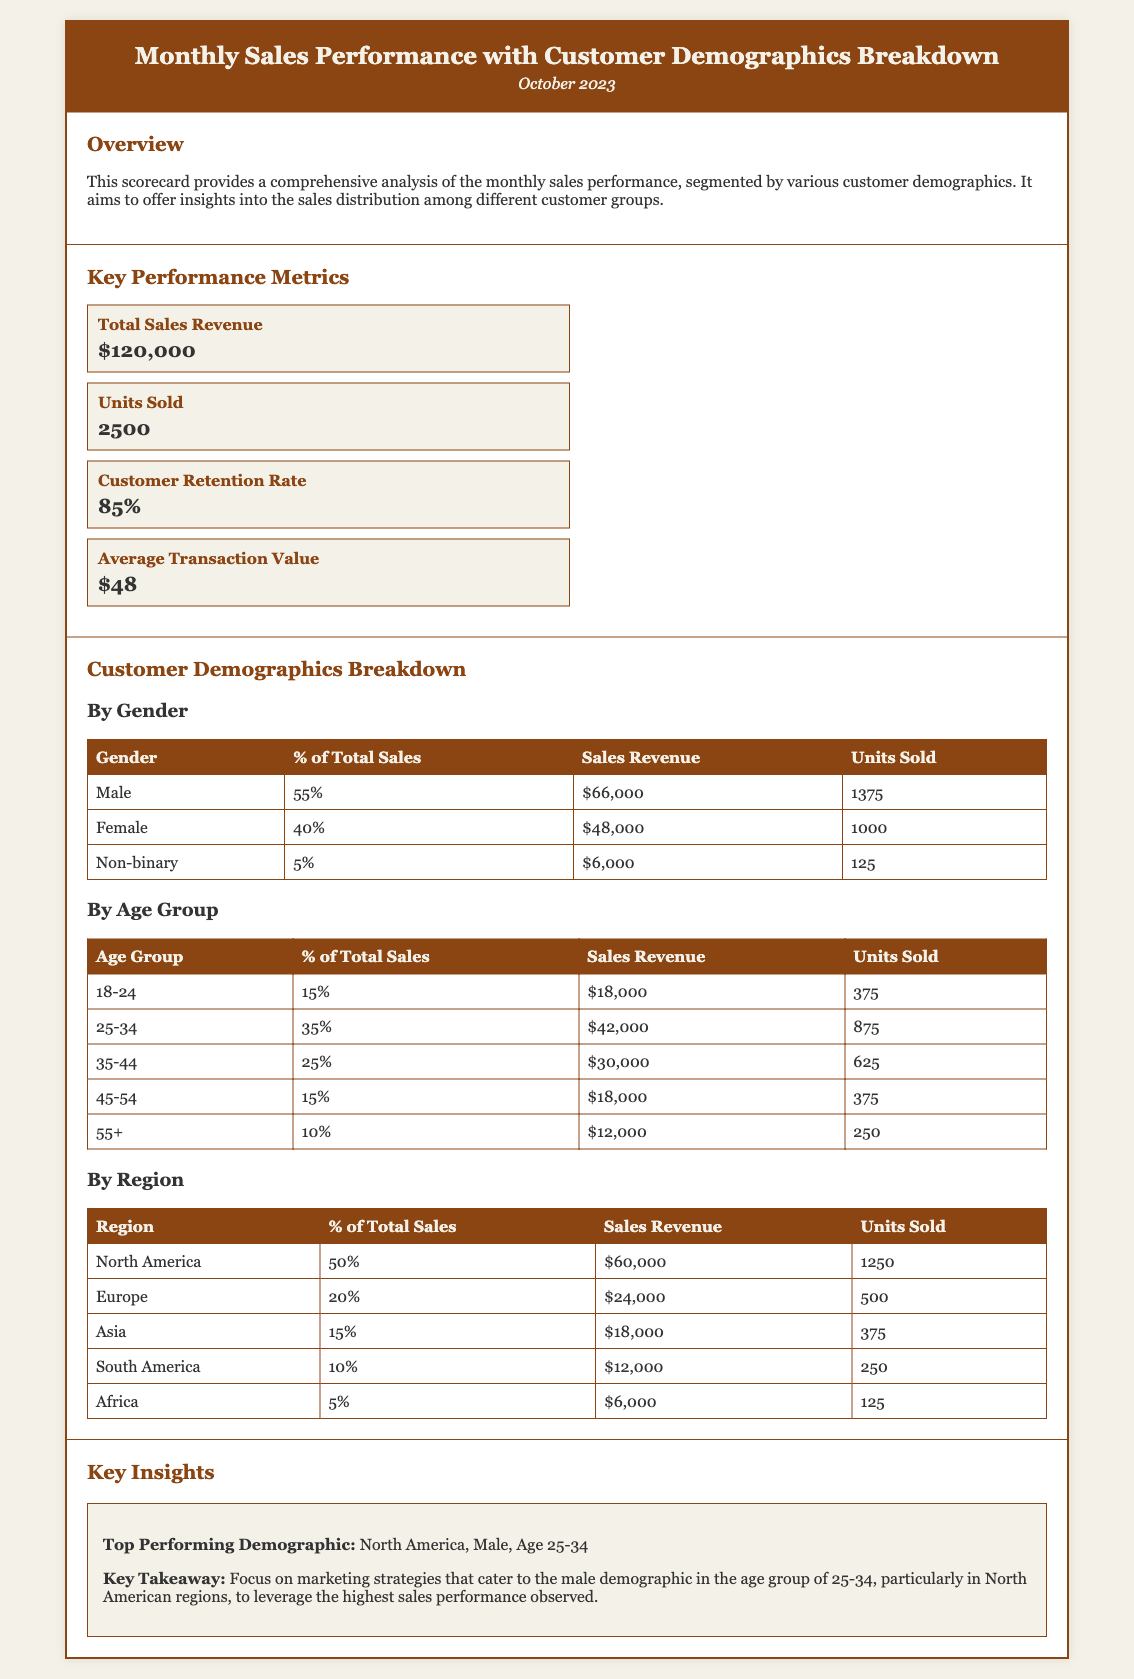what is the total sales revenue? The total sales revenue is recorded at the top of the Key Performance Metrics section in the document.
Answer: $120,000 what percentage of total sales comes from females? This information can be found in the Customer Demographics Breakdown section, specifically under the By Gender table.
Answer: 40% how many units were sold in North America? The units sold for North America are specified in the By Region table within the Customer Demographics Breakdown.
Answer: 1250 which age group contributes the least to total sales? This requires evaluating the By Age Group table to determine which age group has the lowest percentage of total sales.
Answer: 55+ what is the customer retention rate? The customer retention rate is stated in the Key Performance Metrics section of the document.
Answer: 85% what demographic has the highest sales revenue? This insight is presented in the Key Insights section and requires identifying the top-performing demographic from various tables.
Answer: Male, Age 25-34, North America what is the average transaction value? This metric is listed in the Key Performance Metrics section as well.
Answer: $48 how many units were sold by non-binary customers? The number of units sold by non-binary customers can be found in the By Gender table in the document.
Answer: 125 which region has the lowest sales revenue? This can be found by comparing the sales revenue in the By Region table within the Customer Demographics Breakdown.
Answer: Africa 